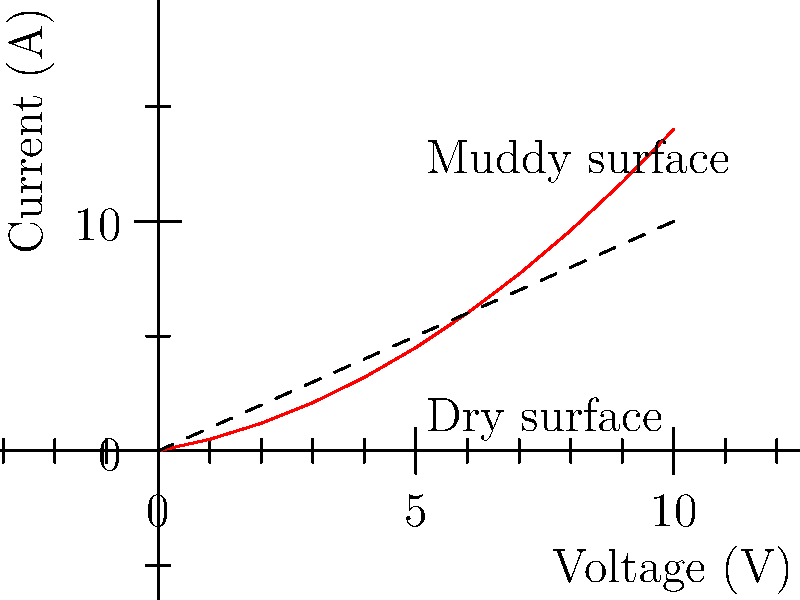Analyzing the voltage-current characteristics of SEAT's traction control system for muddy terrains, what phenomenon does the curve in the graph represent compared to the dashed line, and how does it affect the vehicle's performance? To analyze the voltage-current characteristics:

1. Observe the graph: The solid red curve represents the system's response on muddy terrain, while the dashed line represents an ideal linear response (dry surface).

2. Compare the curves: The solid curve is non-linear and lies above the dashed line.

3. Interpret the non-linearity: This indicates that for a given voltage, the current in muddy conditions is higher than in dry conditions.

4. Understand the implications:
   a) Higher current means increased power delivery to the wheels.
   b) This is beneficial for muddy terrains as it provides more torque to overcome slippery conditions.

5. Relate to traction control:
   a) The system increases power when it detects wheel slip.
   b) This helps maintain traction in challenging muddy conditions.

6. Performance impact:
   a) Improved handling and stability on muddy surfaces.
   b) Better acceleration and control in slippery conditions.
   c) Enhanced comfort for the driver due to smoother power delivery.

The phenomenon represented is the adaptive power delivery of the traction control system, optimized for muddy terrains.
Answer: Adaptive power delivery for improved traction on muddy surfaces 